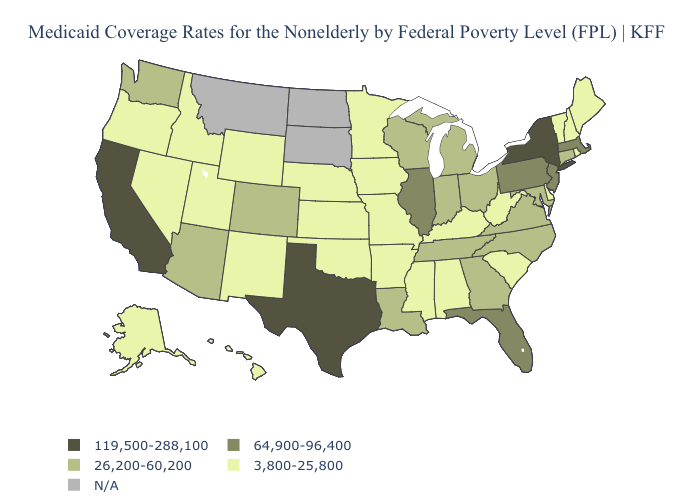Which states hav the highest value in the South?
Give a very brief answer. Texas. What is the value of Louisiana?
Be succinct. 26,200-60,200. Name the states that have a value in the range 3,800-25,800?
Quick response, please. Alabama, Alaska, Arkansas, Delaware, Hawaii, Idaho, Iowa, Kansas, Kentucky, Maine, Minnesota, Mississippi, Missouri, Nebraska, Nevada, New Hampshire, New Mexico, Oklahoma, Oregon, Rhode Island, South Carolina, Utah, Vermont, West Virginia, Wyoming. Name the states that have a value in the range 64,900-96,400?
Be succinct. Florida, Illinois, Massachusetts, New Jersey, Pennsylvania. Among the states that border Oregon , which have the highest value?
Keep it brief. California. Which states have the highest value in the USA?
Short answer required. California, New York, Texas. Name the states that have a value in the range N/A?
Short answer required. Montana, North Dakota, South Dakota. What is the highest value in states that border Maryland?
Keep it brief. 64,900-96,400. What is the value of West Virginia?
Keep it brief. 3,800-25,800. Does Utah have the highest value in the West?
Answer briefly. No. What is the value of Kansas?
Quick response, please. 3,800-25,800. Is the legend a continuous bar?
Quick response, please. No. What is the value of Maryland?
Quick response, please. 26,200-60,200. 